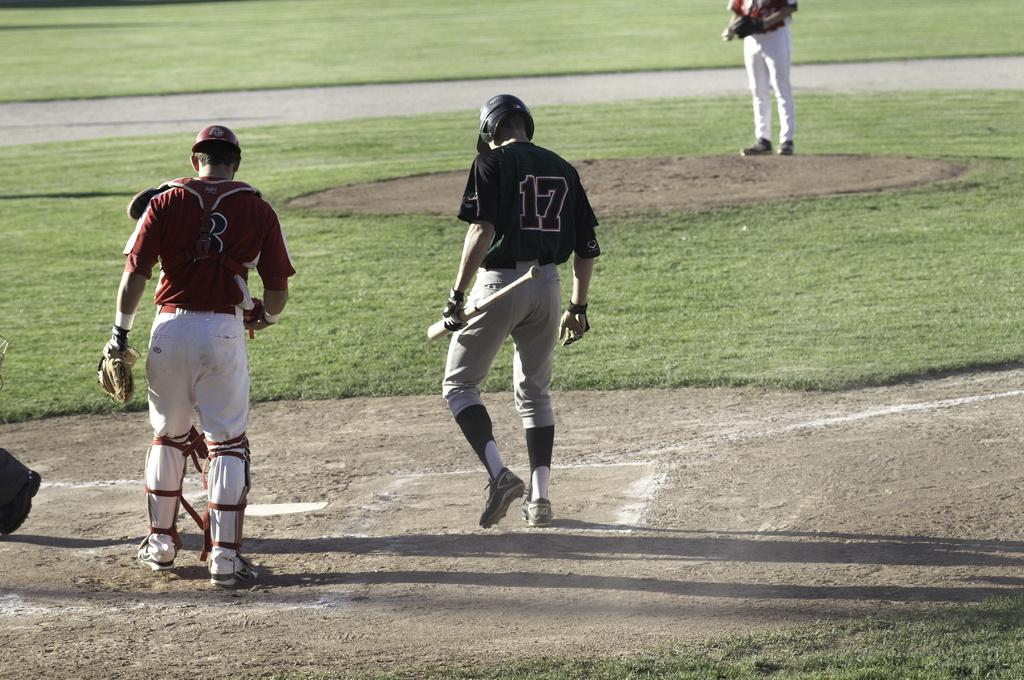<image>
Share a concise interpretation of the image provided. some baseball players with the hitter wearing 17 